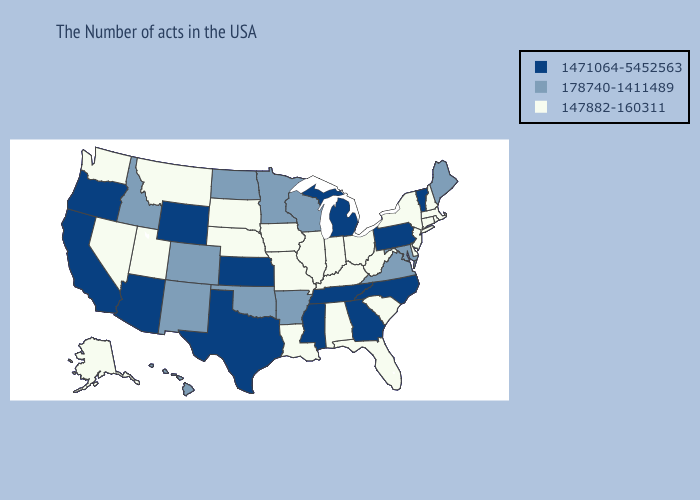Name the states that have a value in the range 147882-160311?
Write a very short answer. Massachusetts, Rhode Island, New Hampshire, Connecticut, New York, New Jersey, Delaware, South Carolina, West Virginia, Ohio, Florida, Kentucky, Indiana, Alabama, Illinois, Louisiana, Missouri, Iowa, Nebraska, South Dakota, Utah, Montana, Nevada, Washington, Alaska. What is the lowest value in states that border Idaho?
Concise answer only. 147882-160311. Does Arizona have a lower value than Michigan?
Answer briefly. No. Among the states that border Minnesota , which have the highest value?
Answer briefly. Wisconsin, North Dakota. How many symbols are there in the legend?
Quick response, please. 3. Does Alabama have the lowest value in the USA?
Write a very short answer. Yes. What is the value of Colorado?
Write a very short answer. 178740-1411489. What is the lowest value in the USA?
Keep it brief. 147882-160311. Name the states that have a value in the range 147882-160311?
Give a very brief answer. Massachusetts, Rhode Island, New Hampshire, Connecticut, New York, New Jersey, Delaware, South Carolina, West Virginia, Ohio, Florida, Kentucky, Indiana, Alabama, Illinois, Louisiana, Missouri, Iowa, Nebraska, South Dakota, Utah, Montana, Nevada, Washington, Alaska. Does Pennsylvania have a higher value than Missouri?
Short answer required. Yes. Which states have the highest value in the USA?
Write a very short answer. Vermont, Pennsylvania, North Carolina, Georgia, Michigan, Tennessee, Mississippi, Kansas, Texas, Wyoming, Arizona, California, Oregon. What is the value of Colorado?
Write a very short answer. 178740-1411489. 